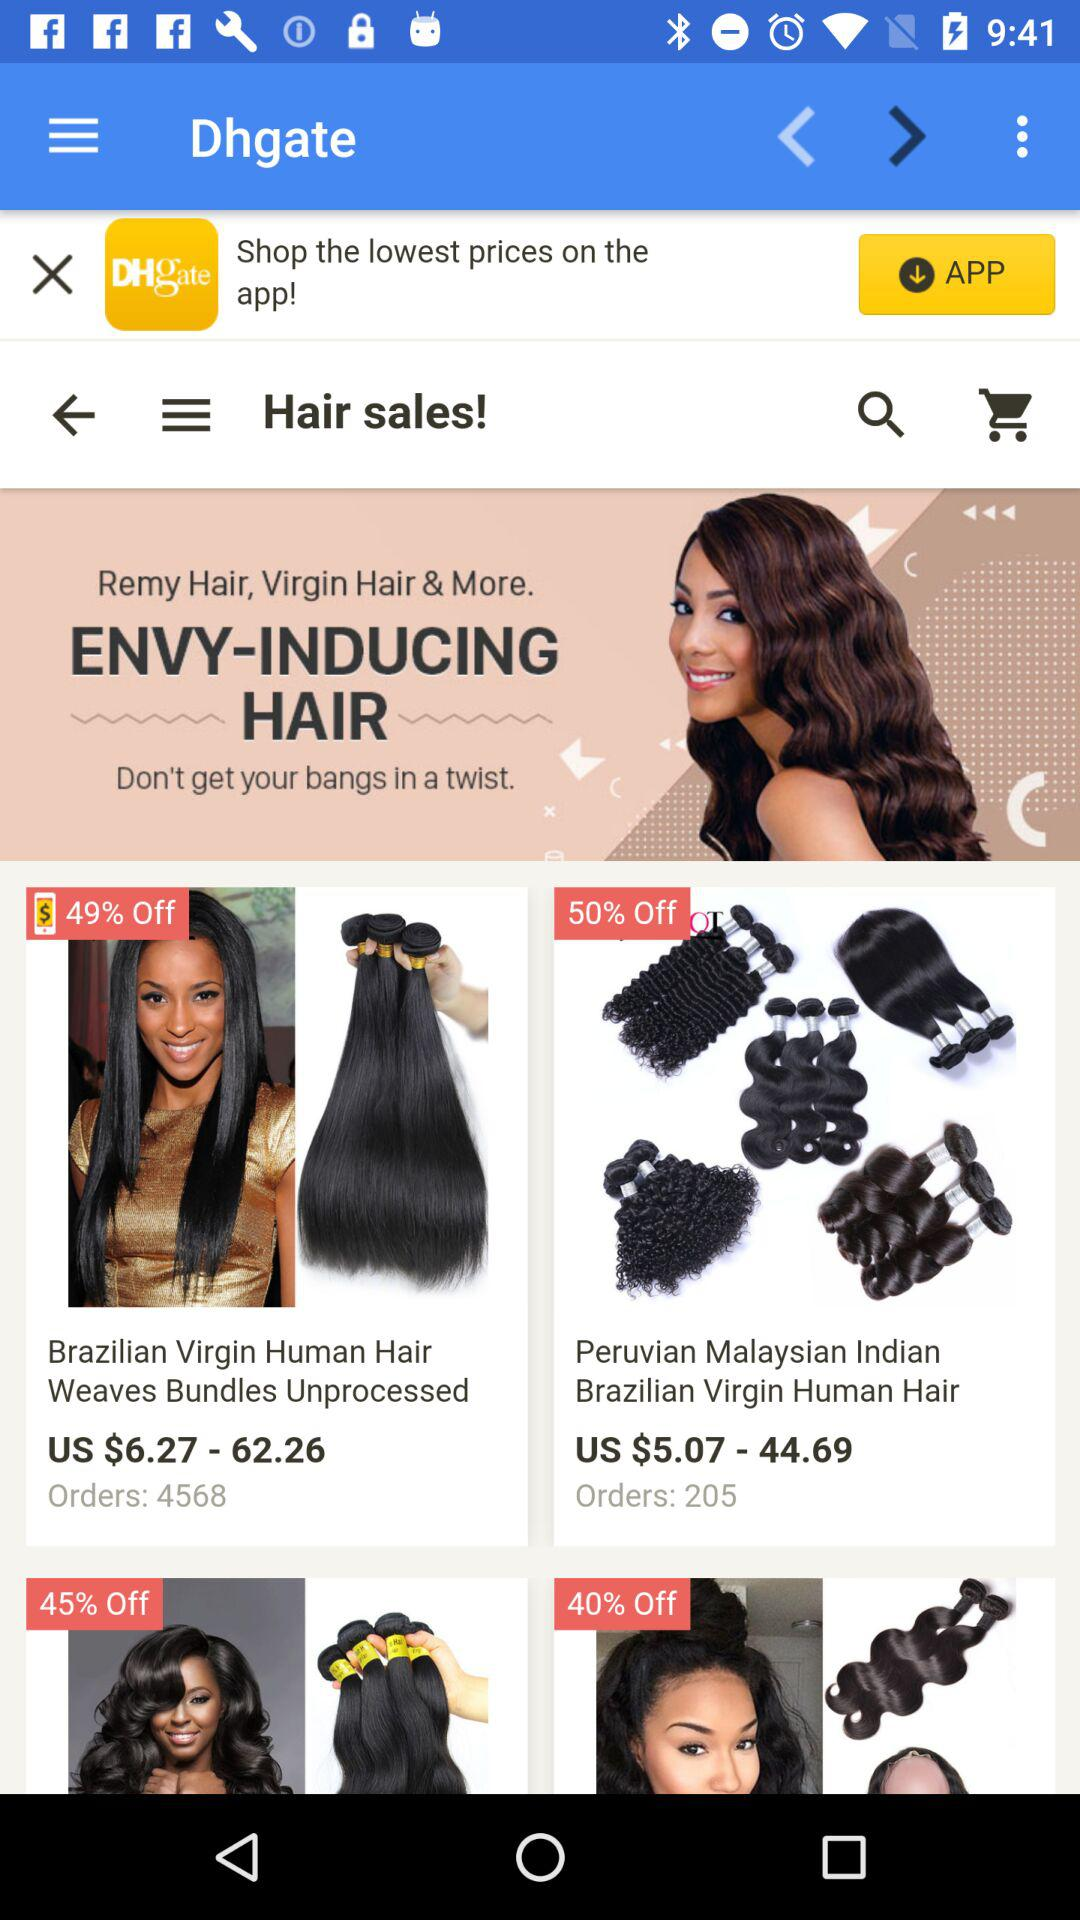What is the order number for Brazilian Virgin Human Hair? The order number is 4568. 